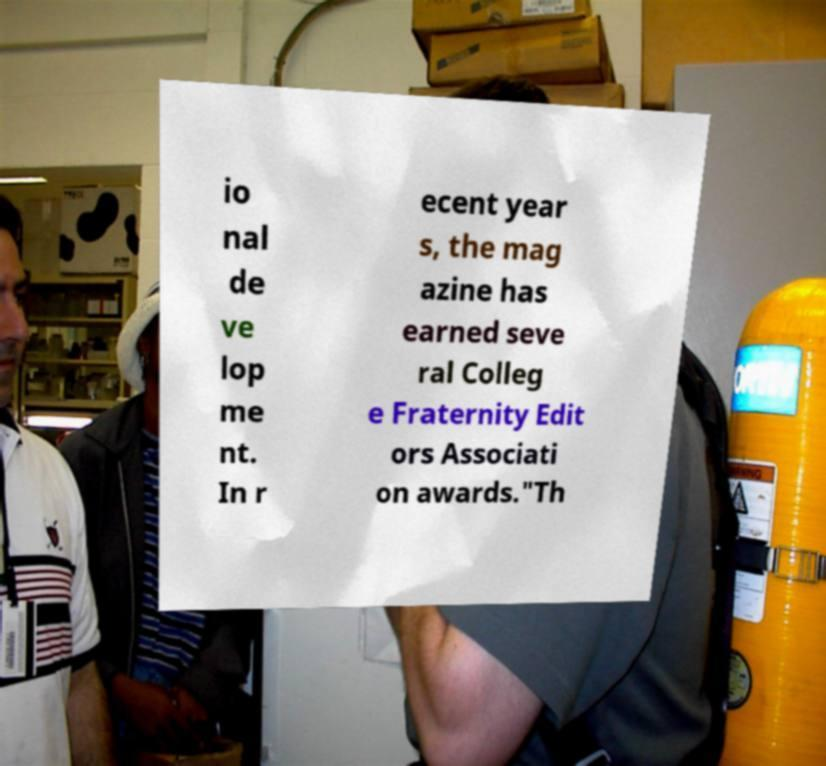Can you read and provide the text displayed in the image?This photo seems to have some interesting text. Can you extract and type it out for me? io nal de ve lop me nt. In r ecent year s, the mag azine has earned seve ral Colleg e Fraternity Edit ors Associati on awards."Th 